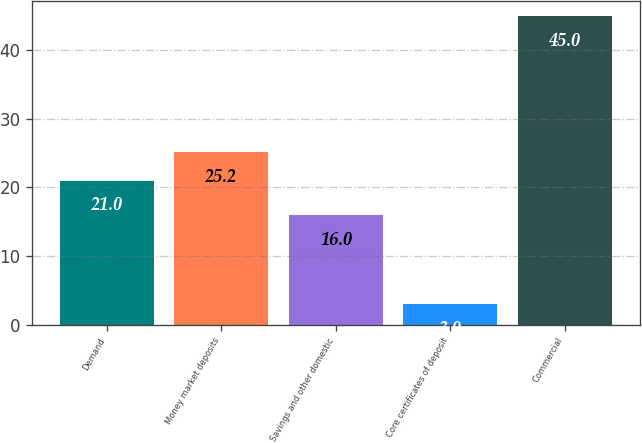Convert chart. <chart><loc_0><loc_0><loc_500><loc_500><bar_chart><fcel>Demand<fcel>Money market deposits<fcel>Savings and other domestic<fcel>Core certificates of deposit<fcel>Commercial<nl><fcel>21<fcel>25.2<fcel>16<fcel>3<fcel>45<nl></chart> 